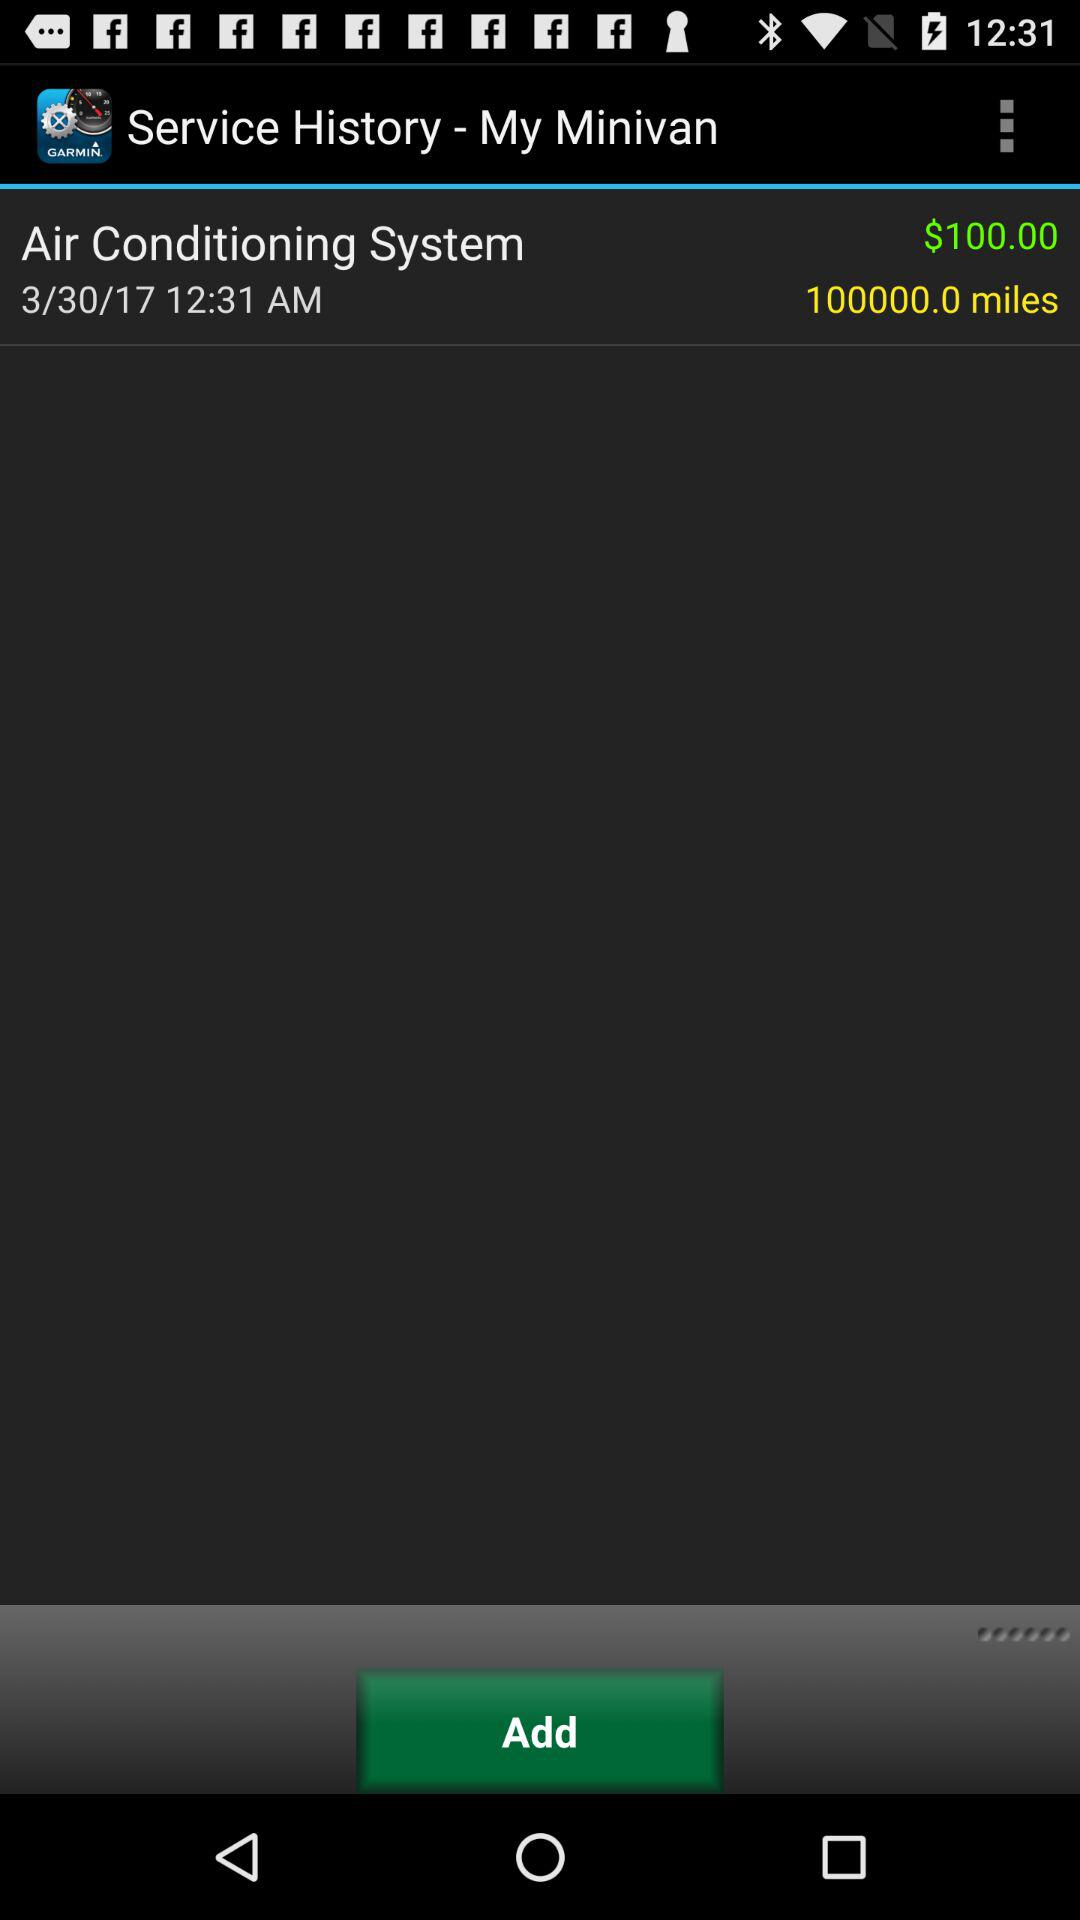What was the date and time of the service?
Answer the question using a single word or phrase. 3/30/17 12:31 AM 